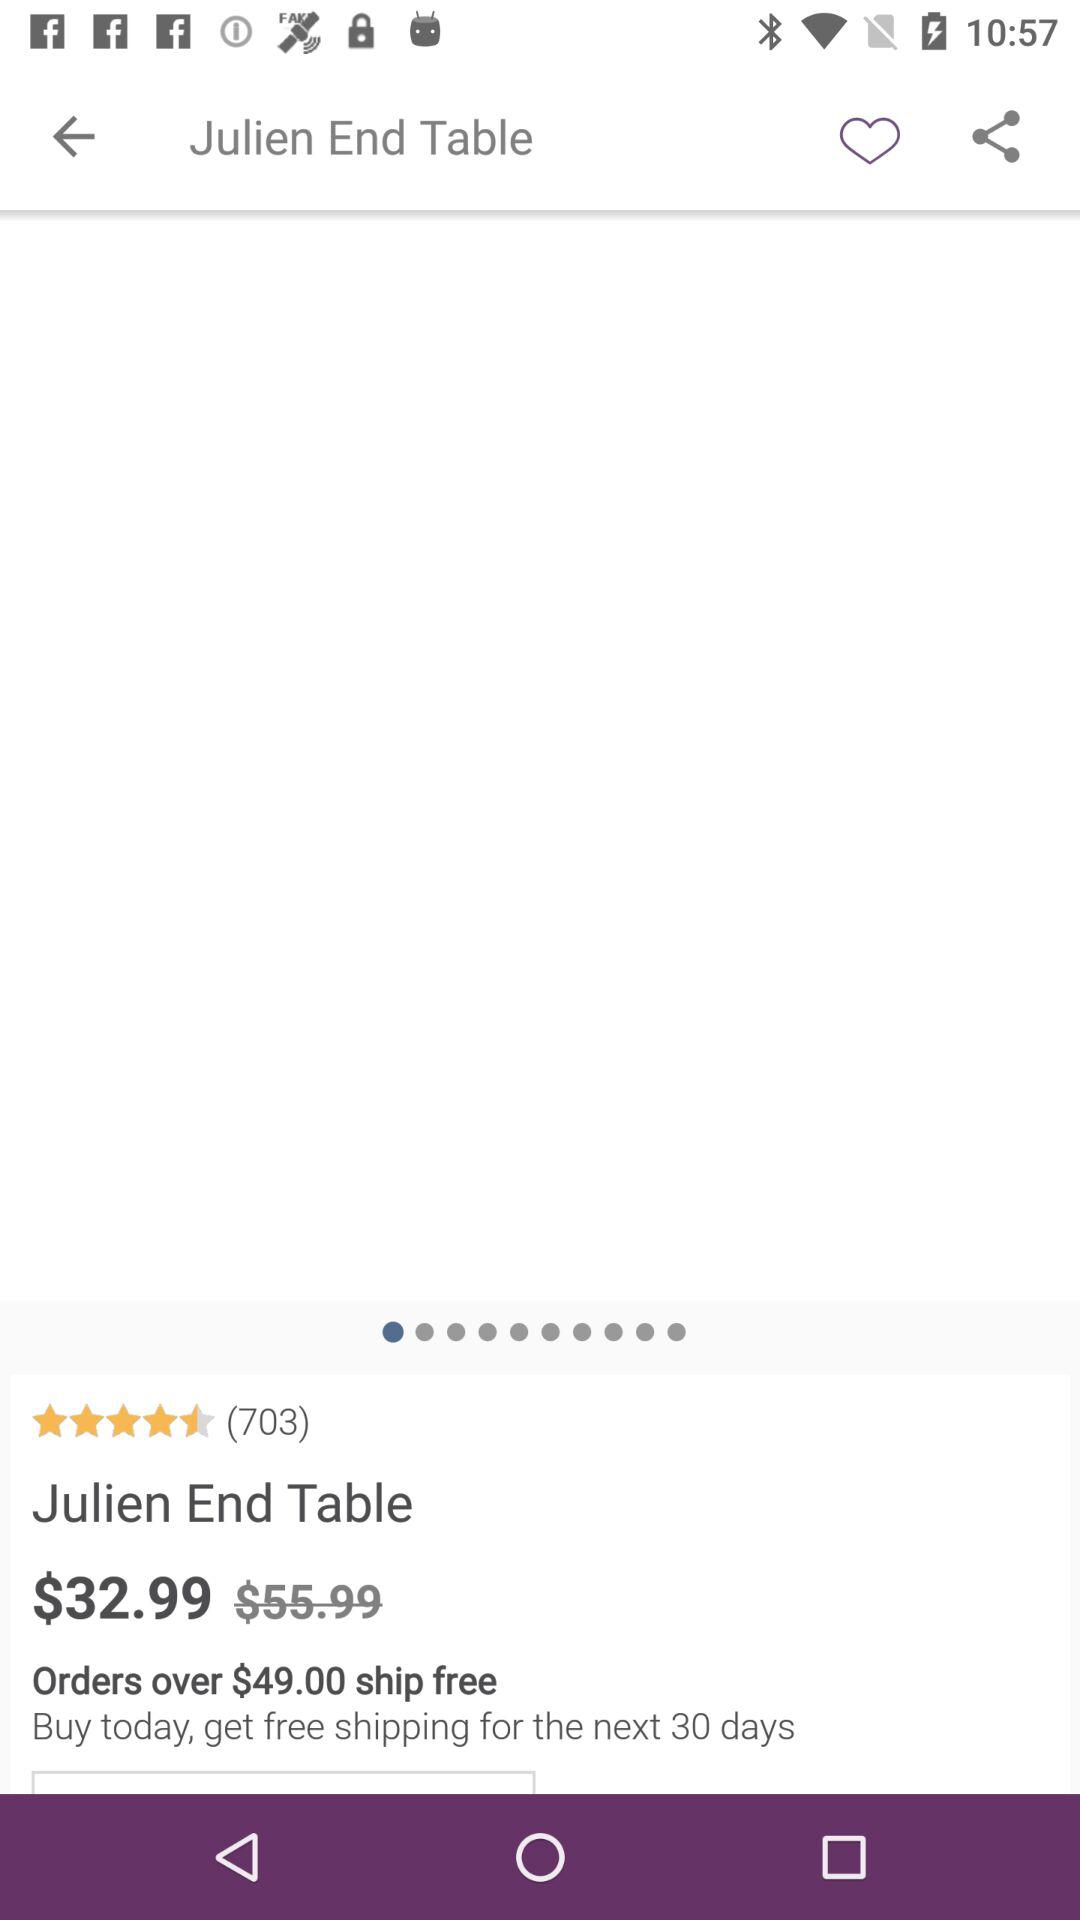What's the price of the "Julien End Table"? The price is $32.99. 